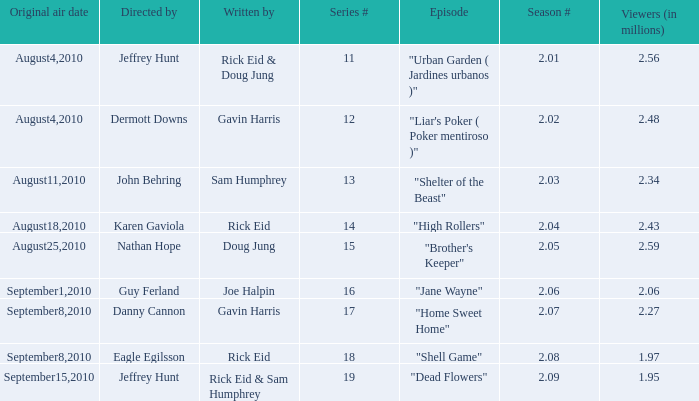Parse the full table. {'header': ['Original air date', 'Directed by', 'Written by', 'Series #', 'Episode', 'Season #', 'Viewers (in millions)'], 'rows': [['August4,2010', 'Jeffrey Hunt', 'Rick Eid & Doug Jung', '11', '"Urban Garden ( Jardines urbanos )"', '2.01', '2.56'], ['August4,2010', 'Dermott Downs', 'Gavin Harris', '12', '"Liar\'s Poker ( Poker mentiroso )"', '2.02', '2.48'], ['August11,2010', 'John Behring', 'Sam Humphrey', '13', '"Shelter of the Beast"', '2.03', '2.34'], ['August18,2010', 'Karen Gaviola', 'Rick Eid', '14', '"High Rollers"', '2.04', '2.43'], ['August25,2010', 'Nathan Hope', 'Doug Jung', '15', '"Brother\'s Keeper"', '2.05', '2.59'], ['September1,2010', 'Guy Ferland', 'Joe Halpin', '16', '"Jane Wayne"', '2.06', '2.06'], ['September8,2010', 'Danny Cannon', 'Gavin Harris', '17', '"Home Sweet Home"', '2.07', '2.27'], ['September8,2010', 'Eagle Egilsson', 'Rick Eid', '18', '"Shell Game"', '2.08', '1.97'], ['September15,2010', 'Jeffrey Hunt', 'Rick Eid & Sam Humphrey', '19', '"Dead Flowers"', '2.09', '1.95']]} What is the amount of viewers if the series number is 14? 2.43. 